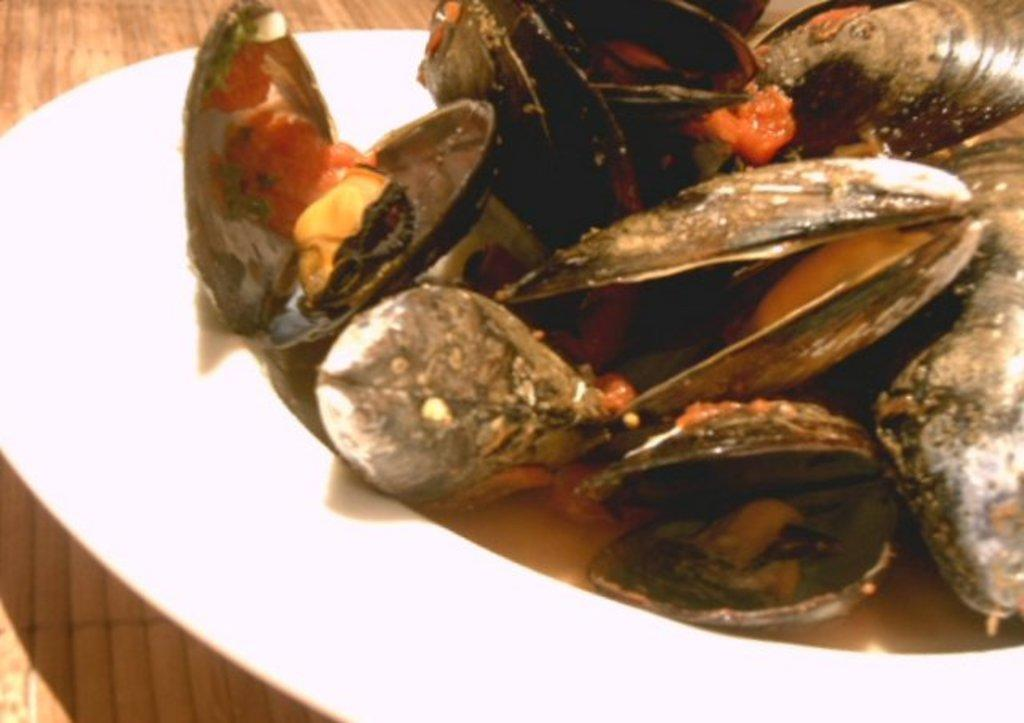What type of objects can be seen in the image? There are seashells in the image. How are the seashells arranged or displayed? The seashells are in a plate. Where is the plate with seashells located? The plate is on a platform. What type of nerve can be seen in the image? There is no nerve present in the image; it features seashells in a plate on a platform. 